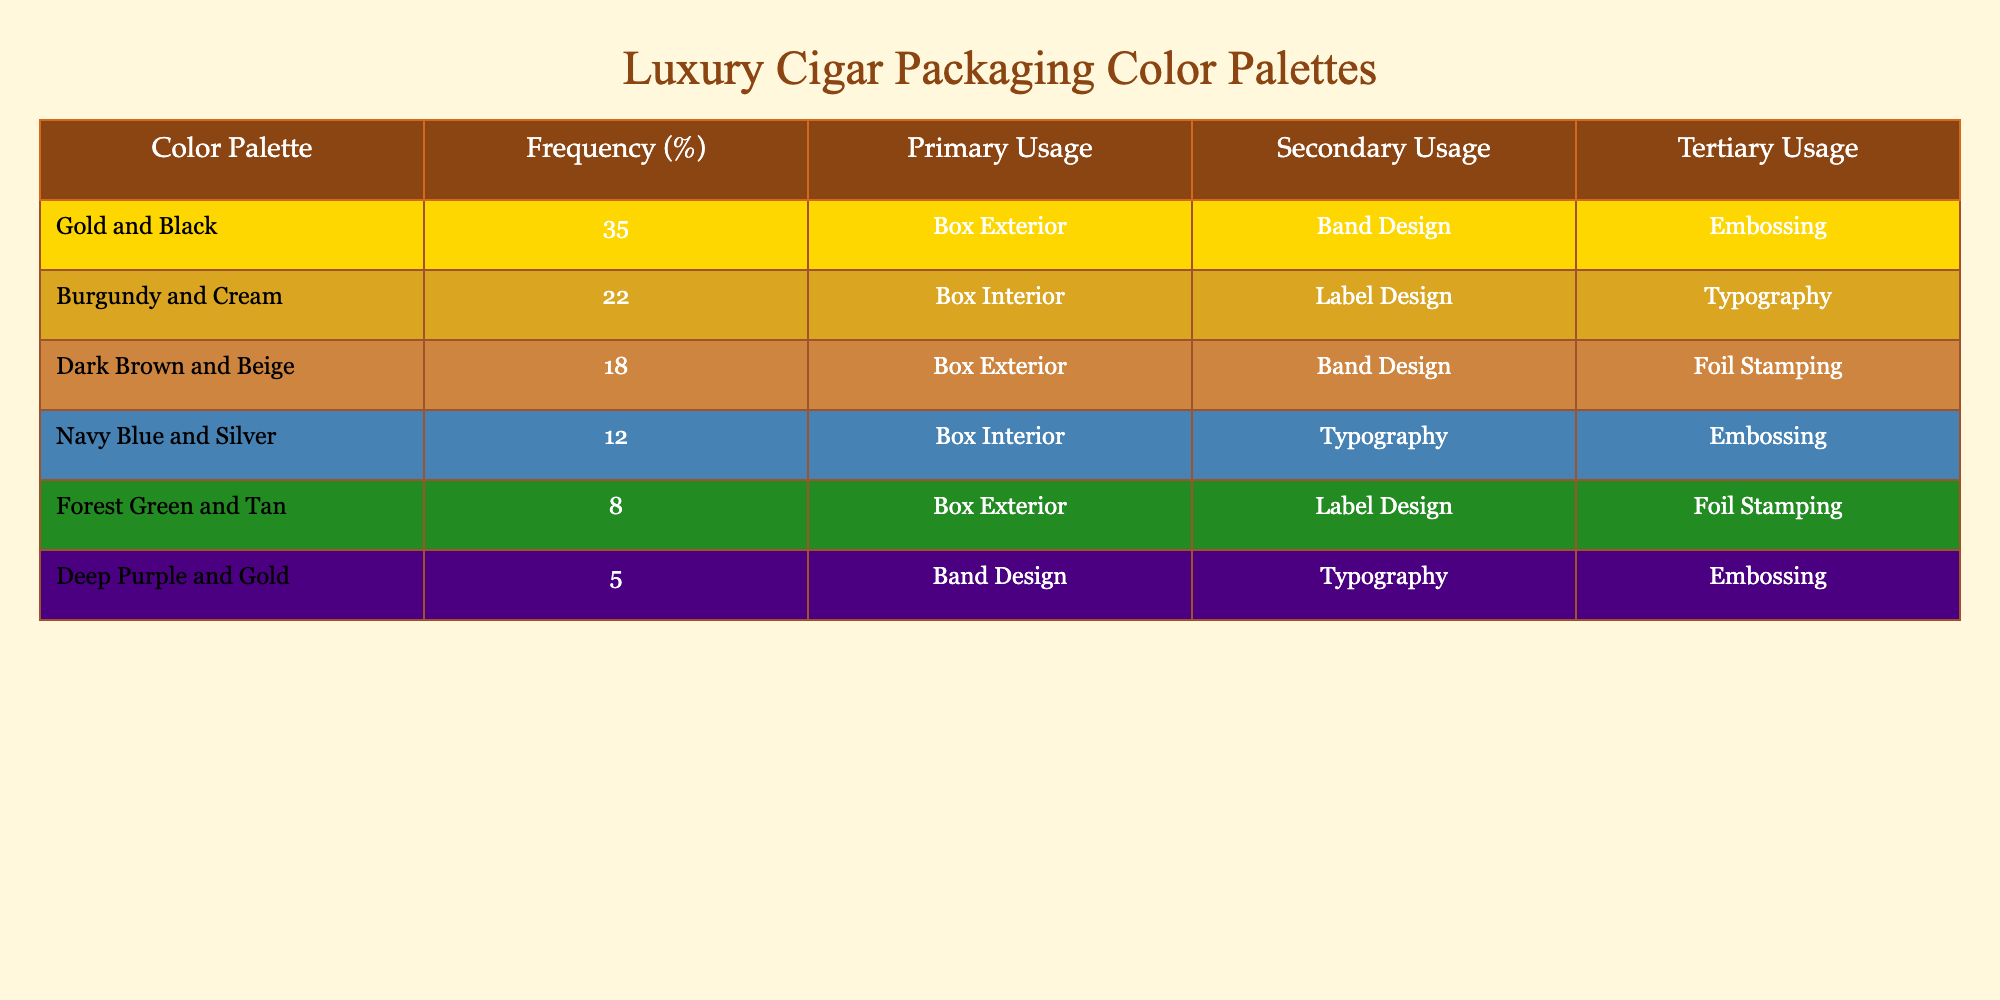What is the most used color palette in luxury cigar packaging designs? The table lists the frequency of color palettes, and "Gold and Black" has the highest frequency of 35%.
Answer: Gold and Black What percentage of the usage does Burgundy and Cream represent? The table shows that "Burgundy and Cream" has a frequency of 22%.
Answer: 22% Are there more color palettes that primarily use Band Design or Box Exterior? "Box Exterior" is listed under two color palettes (Gold and Black, Dark Brown and Beige), while "Band Design" is listed under two palettes as well (Gold and Black, Deep Purple and Gold), so they are equal.
Answer: Yes What is the total frequency percentage for Box Exterior usage? The table indicates that Box Exterior is used in "Gold and Black" (35%) and "Dark Brown and Beige" (18%). Adding these gives 35 + 18 = 53%.
Answer: 53% Does the table indicate that Dark Brown and Beige are used more for Box Exterior compared to Burgundy and Cream for any purpose? "Dark Brown and Beige" is listed for "Box Exterior" usage, while "Burgundy and Cream" is used for "Box Interior." Since these are different primary usages, a direct comparison doesn’t apply correctly.
Answer: No Which color palette has the least frequency usage and for what is it primarily used? The table shows that "Deep Purple and Gold" has the least frequency at 5%, and it is primarily used for Band Design.
Answer: Deep Purple and Gold If we combine the frequencies of the top two color palettes, what percentage do they represent of the total? The top two palettes have frequencies of 35% and 22%, summing to 57%. The total is 100%, so this represents 57% of the total.
Answer: 57% Which color palettes feature Foil Stamping as a usage? The table shows that both "Dark Brown and Beige" and "Forest Green and Tan" feature Foil Stamping as a tertiary usage.
Answer: Dark Brown and Beige, Forest Green and Tan What is the average frequency of color palettes that are primarily used for Box Exterior? The average frequency for the two Box Exterior palettes ("Gold and Black" and "Dark Brown and Beige") is (35 + 18) / 2 = 26.5%.
Answer: 26.5% Is there a color palette that is exclusively used for Typography? Based on the table, "Navy Blue and Silver" and "Deep Purple and Gold" have Typography listed as either secondary or tertiary usage, but there is no palette exclusively used for Typography.
Answer: No 